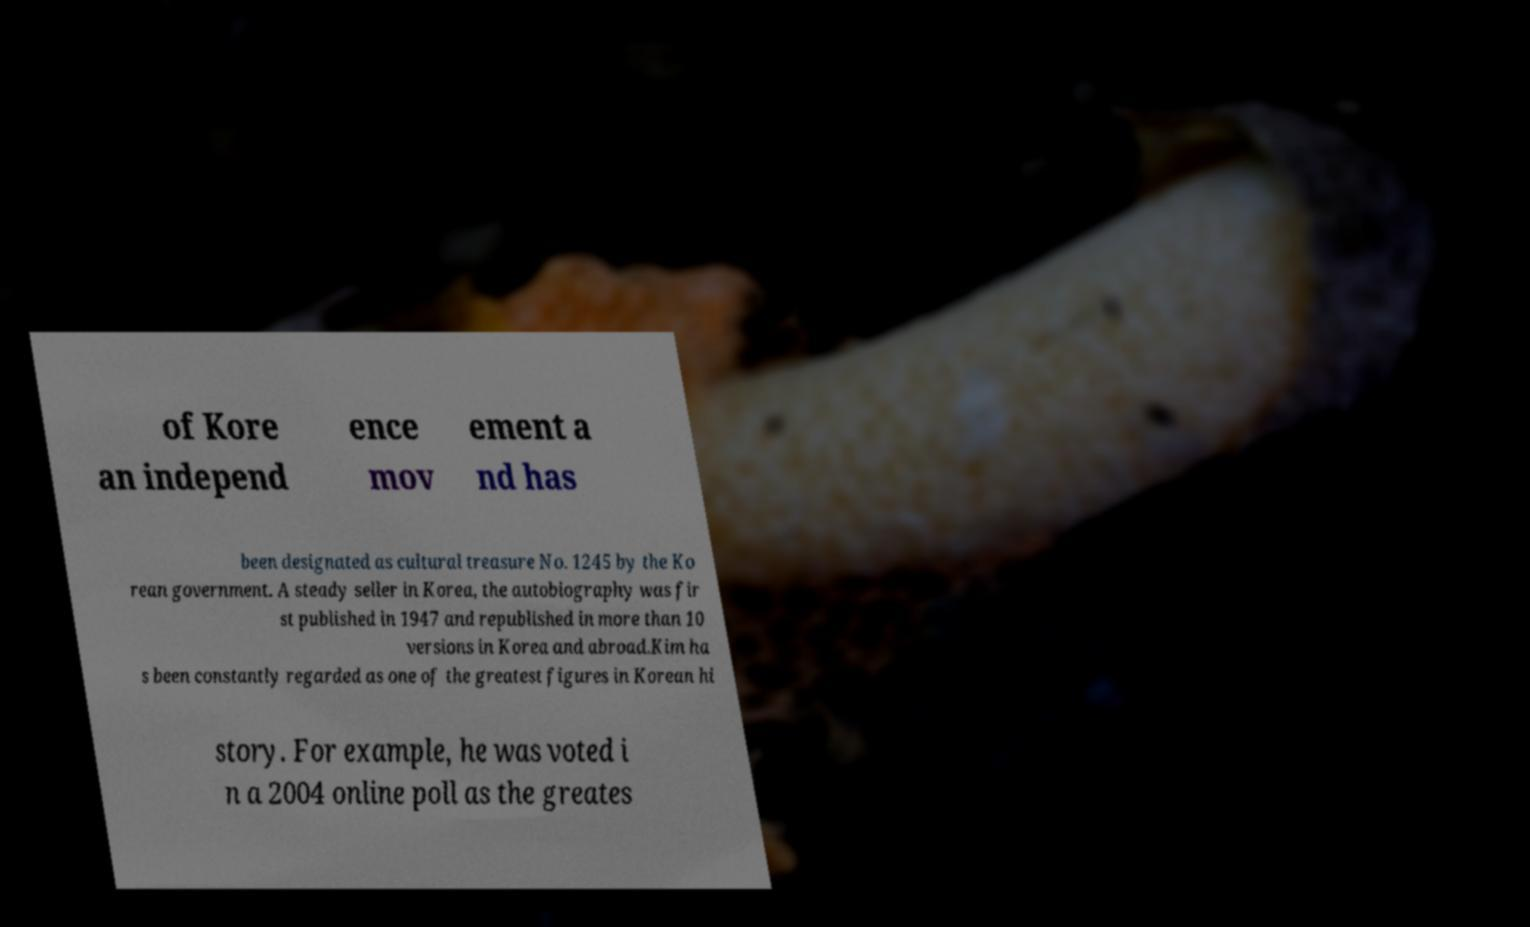Could you extract and type out the text from this image? of Kore an independ ence mov ement a nd has been designated as cultural treasure No. 1245 by the Ko rean government. A steady seller in Korea, the autobiography was fir st published in 1947 and republished in more than 10 versions in Korea and abroad.Kim ha s been constantly regarded as one of the greatest figures in Korean hi story. For example, he was voted i n a 2004 online poll as the greates 